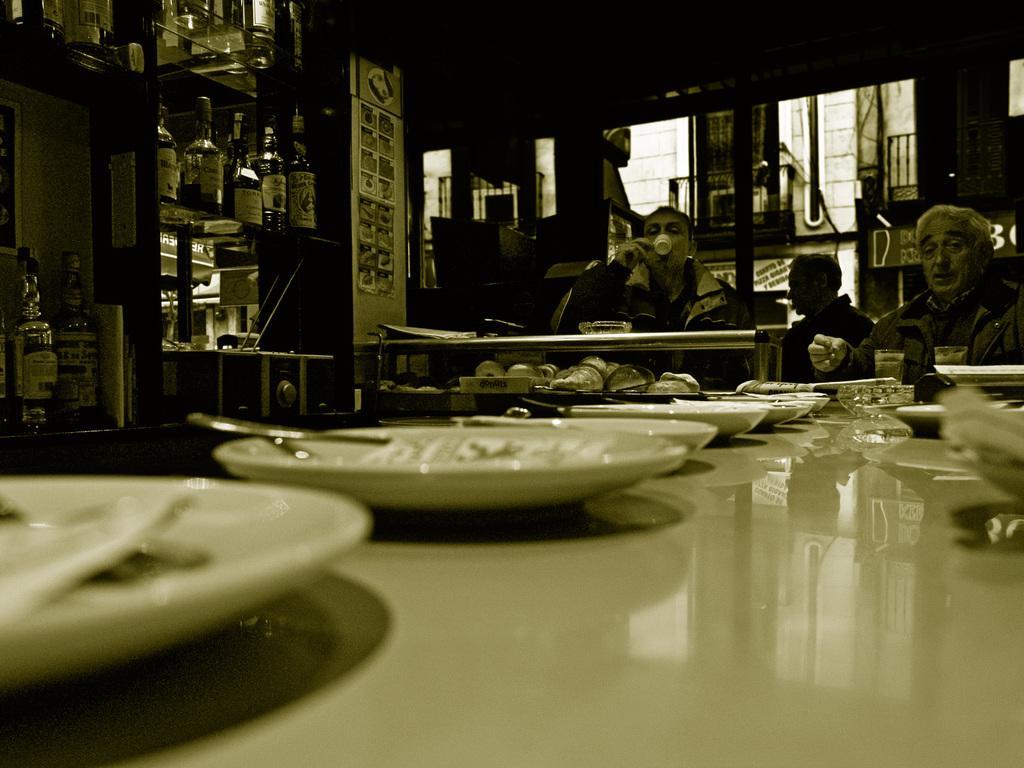Can you describe this image briefly? This is a picture taken in a restaurant, there are a group of people sitting on chairs and a man in a jacket was drinking something in a cup. In front of these people there is a table on the table there are plates, spoon and a bowl. Behind the people there is a shelf on the shelf there are bottles. 